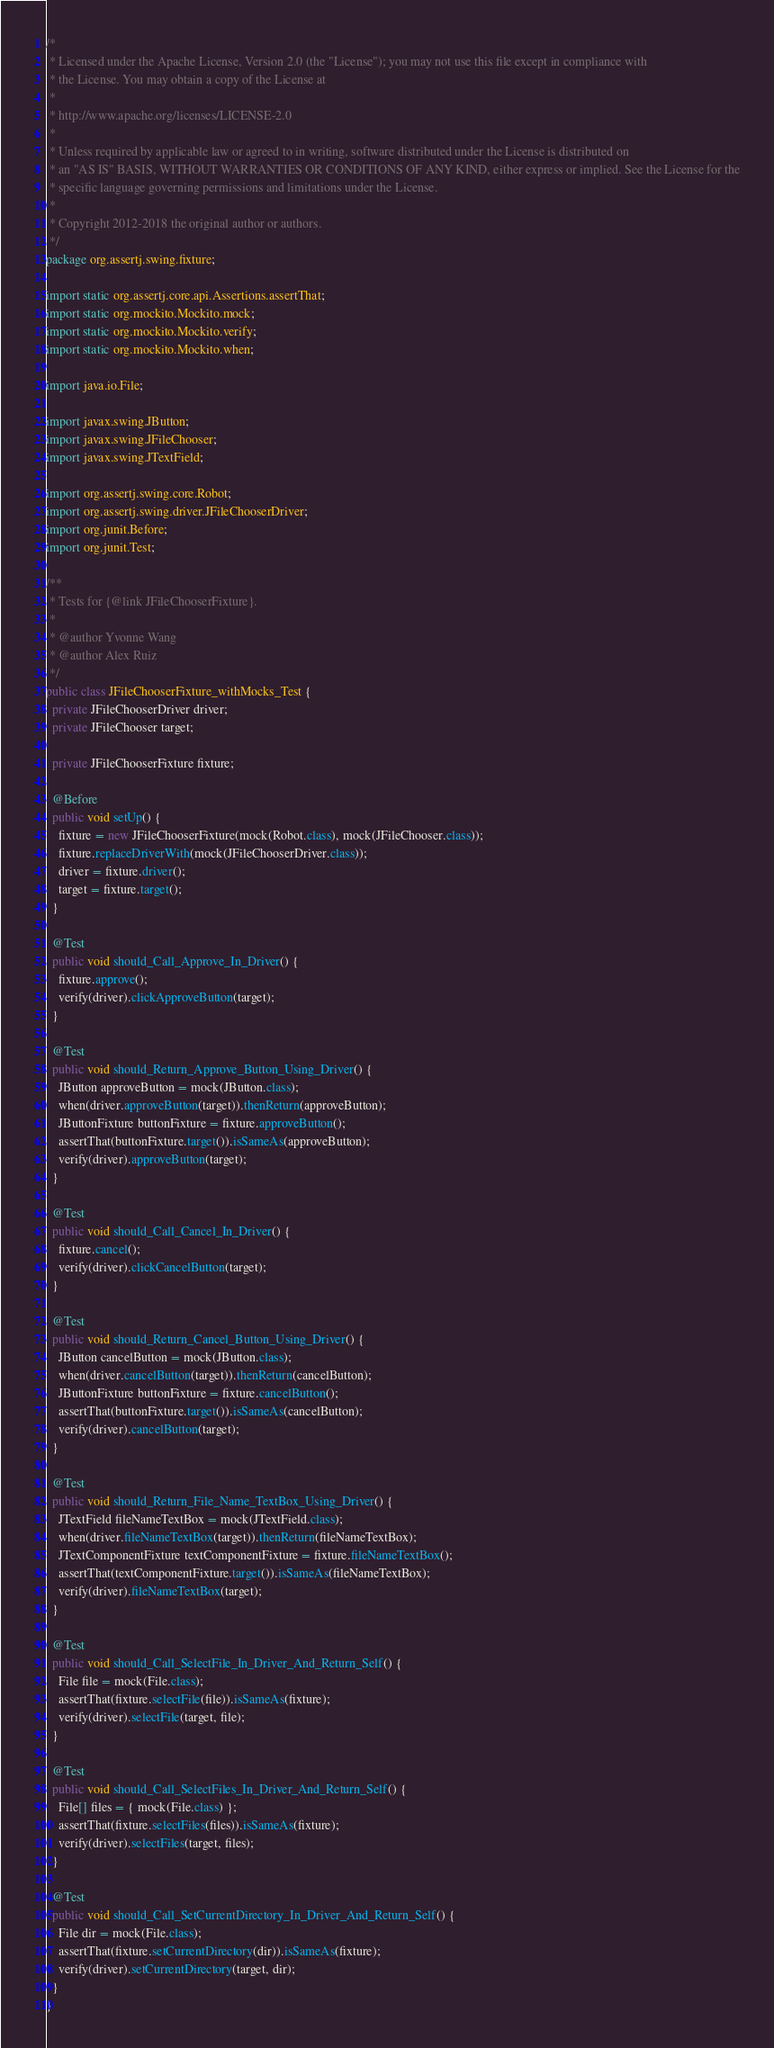<code> <loc_0><loc_0><loc_500><loc_500><_Java_>/*
 * Licensed under the Apache License, Version 2.0 (the "License"); you may not use this file except in compliance with
 * the License. You may obtain a copy of the License at
 *
 * http://www.apache.org/licenses/LICENSE-2.0
 *
 * Unless required by applicable law or agreed to in writing, software distributed under the License is distributed on
 * an "AS IS" BASIS, WITHOUT WARRANTIES OR CONDITIONS OF ANY KIND, either express or implied. See the License for the
 * specific language governing permissions and limitations under the License.
 *
 * Copyright 2012-2018 the original author or authors.
 */
package org.assertj.swing.fixture;

import static org.assertj.core.api.Assertions.assertThat;
import static org.mockito.Mockito.mock;
import static org.mockito.Mockito.verify;
import static org.mockito.Mockito.when;

import java.io.File;

import javax.swing.JButton;
import javax.swing.JFileChooser;
import javax.swing.JTextField;

import org.assertj.swing.core.Robot;
import org.assertj.swing.driver.JFileChooserDriver;
import org.junit.Before;
import org.junit.Test;

/**
 * Tests for {@link JFileChooserFixture}.
 * 
 * @author Yvonne Wang
 * @author Alex Ruiz
 */
public class JFileChooserFixture_withMocks_Test {
  private JFileChooserDriver driver;
  private JFileChooser target;

  private JFileChooserFixture fixture;

  @Before
  public void setUp() {
    fixture = new JFileChooserFixture(mock(Robot.class), mock(JFileChooser.class));
    fixture.replaceDriverWith(mock(JFileChooserDriver.class));
    driver = fixture.driver();
    target = fixture.target();
  }

  @Test
  public void should_Call_Approve_In_Driver() {
    fixture.approve();
    verify(driver).clickApproveButton(target);
  }

  @Test
  public void should_Return_Approve_Button_Using_Driver() {
    JButton approveButton = mock(JButton.class);
    when(driver.approveButton(target)).thenReturn(approveButton);
    JButtonFixture buttonFixture = fixture.approveButton();
    assertThat(buttonFixture.target()).isSameAs(approveButton);
    verify(driver).approveButton(target);
  }

  @Test
  public void should_Call_Cancel_In_Driver() {
    fixture.cancel();
    verify(driver).clickCancelButton(target);
  }

  @Test
  public void should_Return_Cancel_Button_Using_Driver() {
    JButton cancelButton = mock(JButton.class);
    when(driver.cancelButton(target)).thenReturn(cancelButton);
    JButtonFixture buttonFixture = fixture.cancelButton();
    assertThat(buttonFixture.target()).isSameAs(cancelButton);
    verify(driver).cancelButton(target);
  }

  @Test
  public void should_Return_File_Name_TextBox_Using_Driver() {
    JTextField fileNameTextBox = mock(JTextField.class);
    when(driver.fileNameTextBox(target)).thenReturn(fileNameTextBox);
    JTextComponentFixture textComponentFixture = fixture.fileNameTextBox();
    assertThat(textComponentFixture.target()).isSameAs(fileNameTextBox);
    verify(driver).fileNameTextBox(target);
  }

  @Test
  public void should_Call_SelectFile_In_Driver_And_Return_Self() {
    File file = mock(File.class);
    assertThat(fixture.selectFile(file)).isSameAs(fixture);
    verify(driver).selectFile(target, file);
  }

  @Test
  public void should_Call_SelectFiles_In_Driver_And_Return_Self() {
    File[] files = { mock(File.class) };
    assertThat(fixture.selectFiles(files)).isSameAs(fixture);
    verify(driver).selectFiles(target, files);
  }

  @Test
  public void should_Call_SetCurrentDirectory_In_Driver_And_Return_Self() {
    File dir = mock(File.class);
    assertThat(fixture.setCurrentDirectory(dir)).isSameAs(fixture);
    verify(driver).setCurrentDirectory(target, dir);
  }
}
</code> 